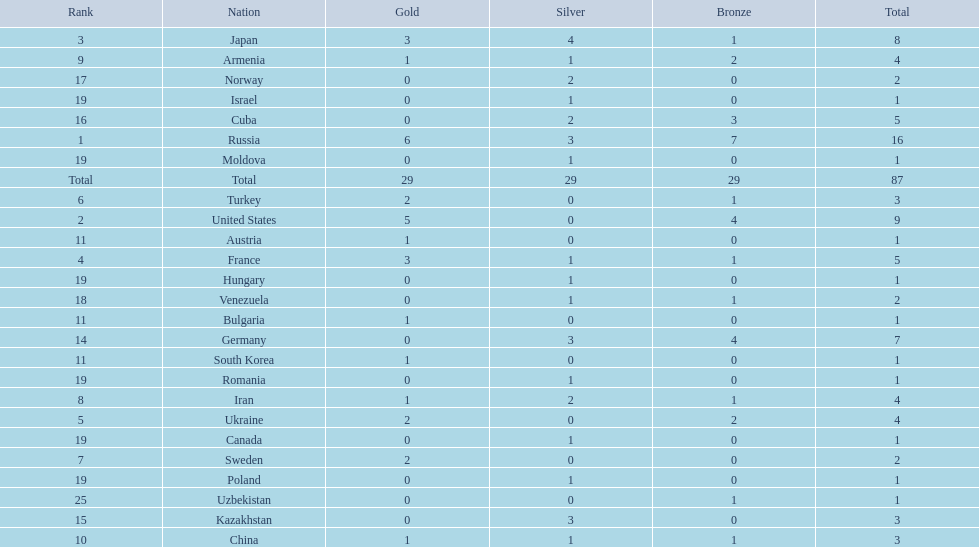Can you parse all the data within this table? {'header': ['Rank', 'Nation', 'Gold', 'Silver', 'Bronze', 'Total'], 'rows': [['3', 'Japan', '3', '4', '1', '8'], ['9', 'Armenia', '1', '1', '2', '4'], ['17', 'Norway', '0', '2', '0', '2'], ['19', 'Israel', '0', '1', '0', '1'], ['16', 'Cuba', '0', '2', '3', '5'], ['1', 'Russia', '6', '3', '7', '16'], ['19', 'Moldova', '0', '1', '0', '1'], ['Total', 'Total', '29', '29', '29', '87'], ['6', 'Turkey', '2', '0', '1', '3'], ['2', 'United States', '5', '0', '4', '9'], ['11', 'Austria', '1', '0', '0', '1'], ['4', 'France', '3', '1', '1', '5'], ['19', 'Hungary', '0', '1', '0', '1'], ['18', 'Venezuela', '0', '1', '1', '2'], ['11', 'Bulgaria', '1', '0', '0', '1'], ['14', 'Germany', '0', '3', '4', '7'], ['11', 'South Korea', '1', '0', '0', '1'], ['19', 'Romania', '0', '1', '0', '1'], ['8', 'Iran', '1', '2', '1', '4'], ['5', 'Ukraine', '2', '0', '2', '4'], ['19', 'Canada', '0', '1', '0', '1'], ['7', 'Sweden', '2', '0', '0', '2'], ['19', 'Poland', '0', '1', '0', '1'], ['25', 'Uzbekistan', '0', '0', '1', '1'], ['15', 'Kazakhstan', '0', '3', '0', '3'], ['10', 'China', '1', '1', '1', '3']]} Which country won only one medal, a bronze medal? Uzbekistan. 